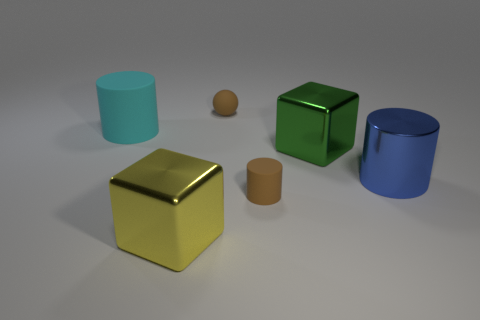Add 4 large cyan blocks. How many objects exist? 10 Subtract all balls. How many objects are left? 5 Subtract 0 purple spheres. How many objects are left? 6 Subtract all tiny gray metallic cylinders. Subtract all big blue cylinders. How many objects are left? 5 Add 6 large yellow metal blocks. How many large yellow metal blocks are left? 7 Add 3 tiny spheres. How many tiny spheres exist? 4 